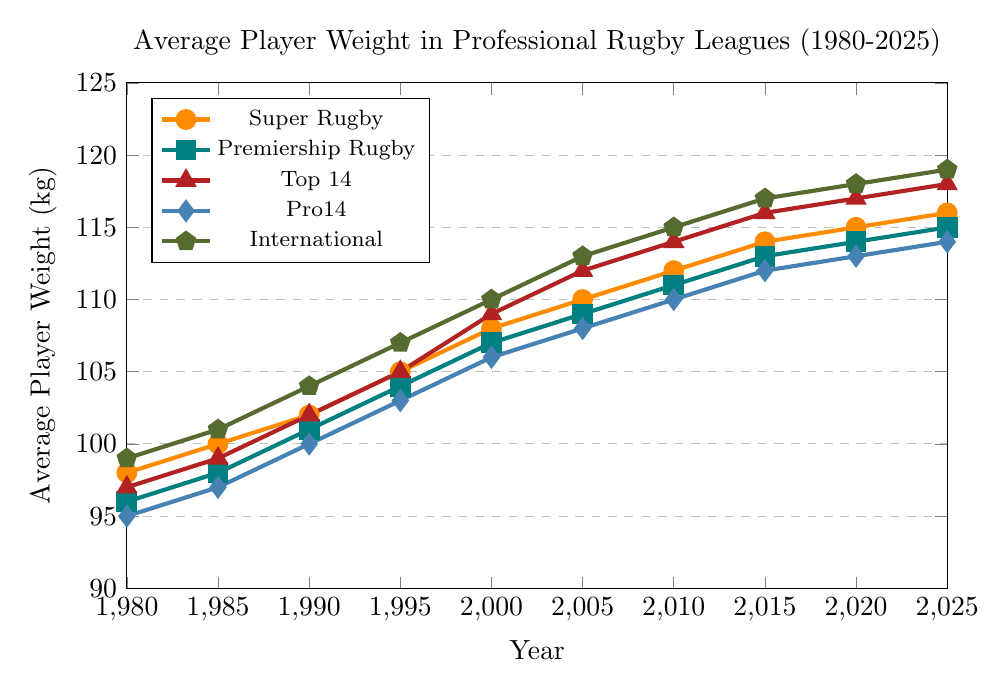How has the average player weight in Pro14 changed from 1980 to 2025? Look at the data points for Pro14 from 1980 to 2025. In 1980, the average weight was 95 kg and in 2025, it is 114 kg. The weight has increased over this period.
Answer: Increased Which league had the highest increase in average player weight from 1980 to 2025? Calculate the difference in average player weight from 1980 to 2025 for each league. The differences are: Super Rugby (118-98 = 18), Premiership Rugby (115-96 = 19), Top 14 (118-97 = 21), Pro14 (114-95 = 19), International (119-99 = 20). Top 14 had the highest increase.
Answer: Top 14 Which league had the highest average player weight in 2005? Look at the data points for all leagues in 2005. Super Rugby: 110 kg, Premiership Rugby: 109 kg, Top 14: 112 kg, Pro14: 108 kg, International: 113 kg. International had the highest average weight.
Answer: International In which year did Premiership Rugby reach an average player weight of 107 kg? Look at the data points for Premiership Rugby. The average weight was 107 kg in the year 2000.
Answer: 2000 Compare the average player weight between Super Rugby and International players in 2020. Look at the data points for Super Rugby and International players in 2020. Super Rugby: 115 kg, International: 118 kg. International players had a higher average weight.
Answer: International What was the approximate average weight of players across all leagues in 1990? Sum the average weights of all leagues in 1990 and divide by the number of leagues (5). (102 + 101 + 102 + 100 + 104)/5 = 101.8 kg.
Answer: 101.8 kg Which league had the smallest increase in average player weight from 1980 to 1995? Calculate the difference in average player weight from 1980 to 1995 for each league. Super Rugby: 105-98 = 7, Premiership Rugby: 104-96 = 8, Top 14: 105-97 = 8, Pro14: 103-95 = 8, International: 107-99 = 8. Super Rugby had the smallest increase.
Answer: Super Rugby In 2025, which two leagues had the closest average player weight? Compare the average player weights of all leagues in 2025. Super Rugby: 116 kg, Premiership Rugby: 115 kg, Top 14: 118 kg, Pro14: 114 kg, International: 119 kg. Super Rugby and Premiership Rugby are the closest at 116 kg and 115 kg.
Answer: Super Rugby and Premiership Rugby How did the average weight of Top 14 players change from 2000 to 2020? Look at the data points for Top 14 from 2000 to 2020. In 2000, the average weight was 109 kg and in 2020, it was 117 kg. The weight increased by 8 kg during this period.
Answer: Increased by 8 kg 